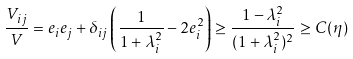Convert formula to latex. <formula><loc_0><loc_0><loc_500><loc_500>\frac { V _ { i j } } { V } = e _ { i } e _ { j } + \delta _ { i j } \left ( \frac { 1 } { 1 + \lambda _ { i } ^ { 2 } } - 2 e _ { i } ^ { 2 } \right ) \geq \frac { 1 - \lambda _ { i } ^ { 2 } } { ( 1 + \lambda _ { i } ^ { 2 } ) ^ { 2 } } \geq C ( \eta )</formula> 